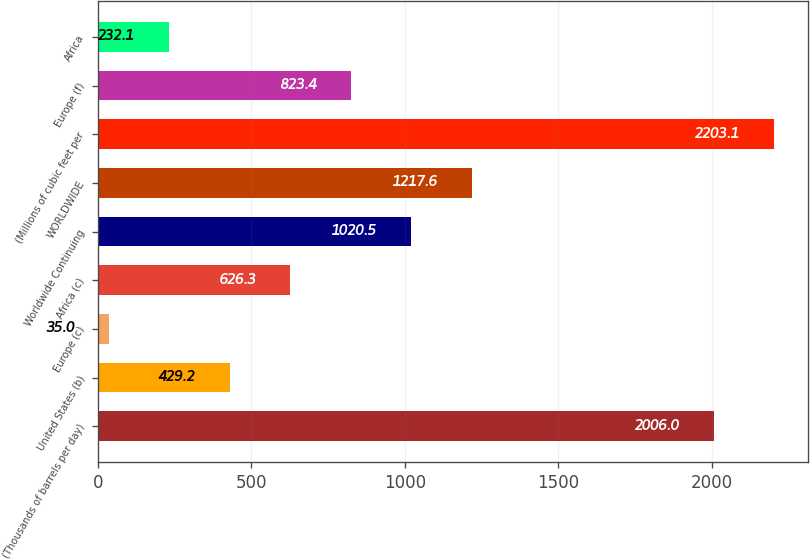<chart> <loc_0><loc_0><loc_500><loc_500><bar_chart><fcel>(Thousands of barrels per day)<fcel>United States (b)<fcel>Europe (c)<fcel>Africa (c)<fcel>Worldwide Continuing<fcel>WORLDWIDE<fcel>(Millions of cubic feet per<fcel>Europe (f)<fcel>Africa<nl><fcel>2006<fcel>429.2<fcel>35<fcel>626.3<fcel>1020.5<fcel>1217.6<fcel>2203.1<fcel>823.4<fcel>232.1<nl></chart> 